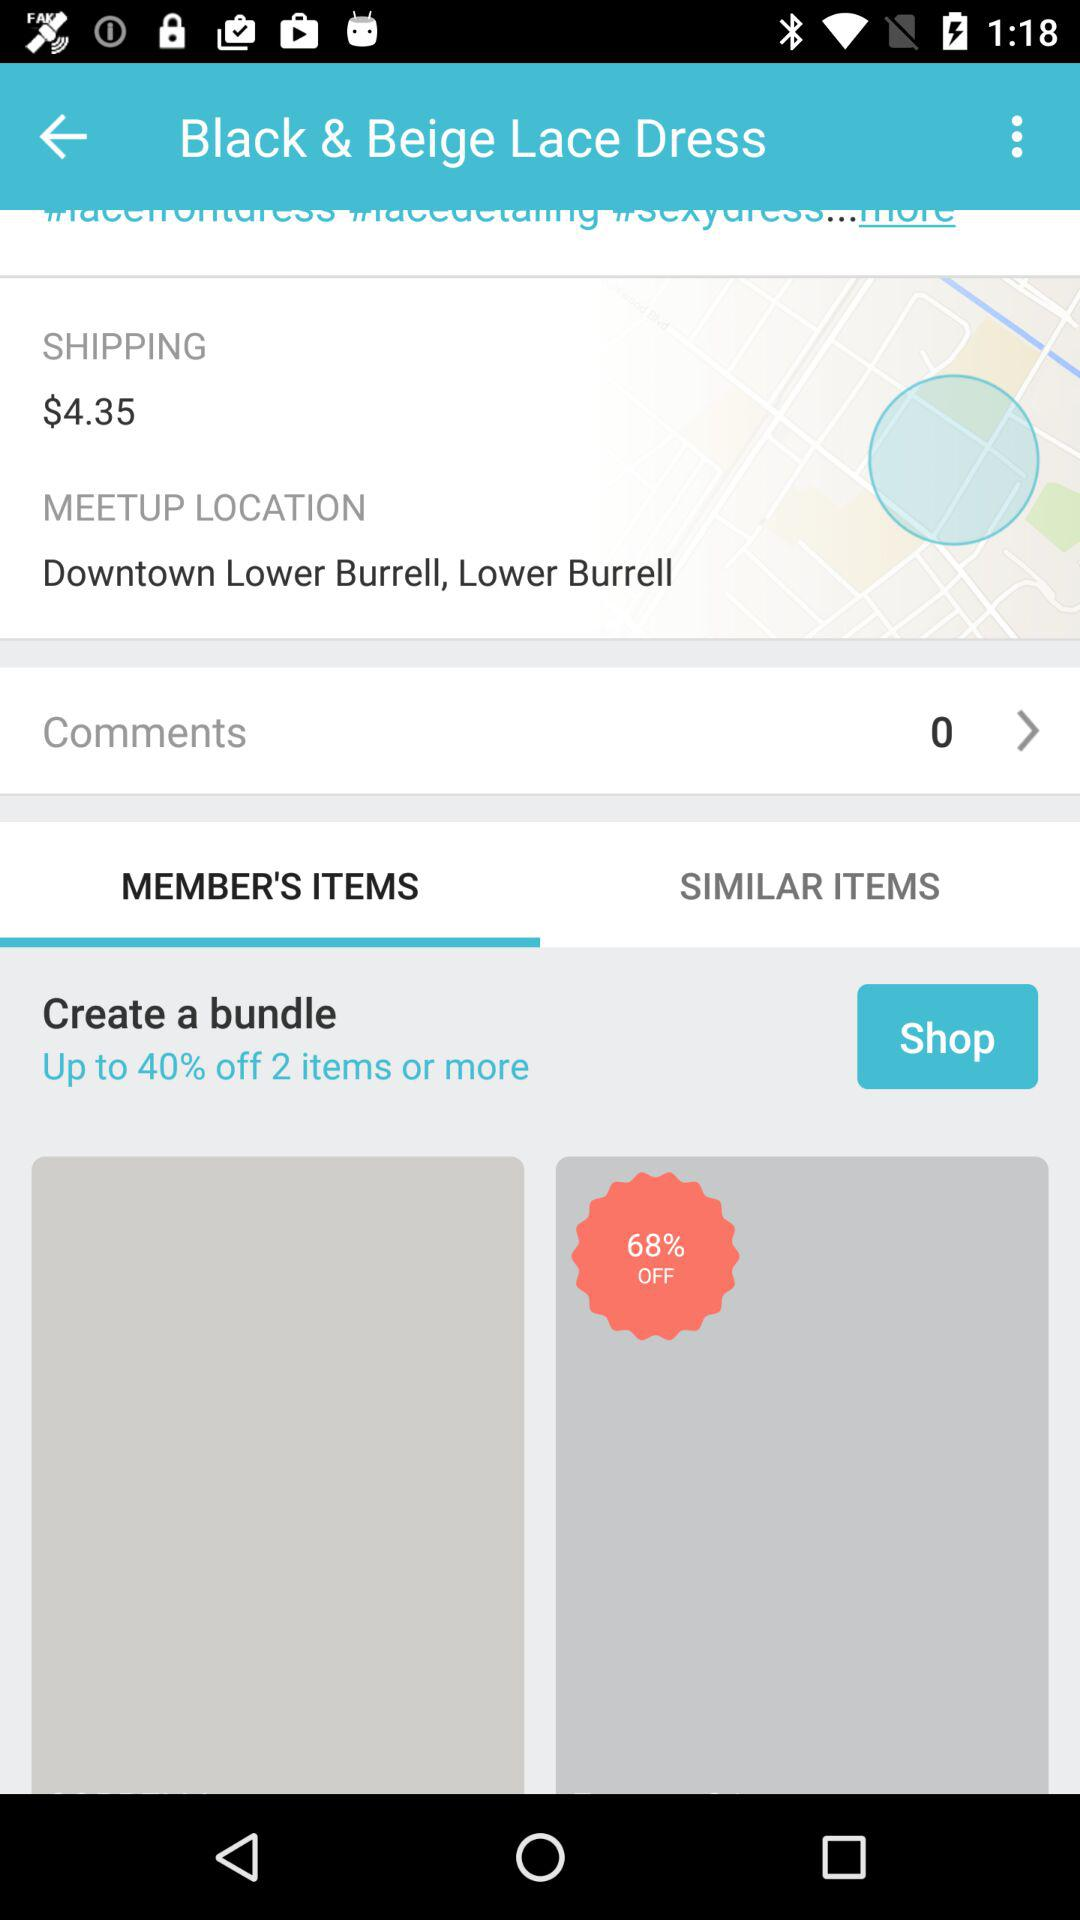How many comments are there? There are 0 comments. 